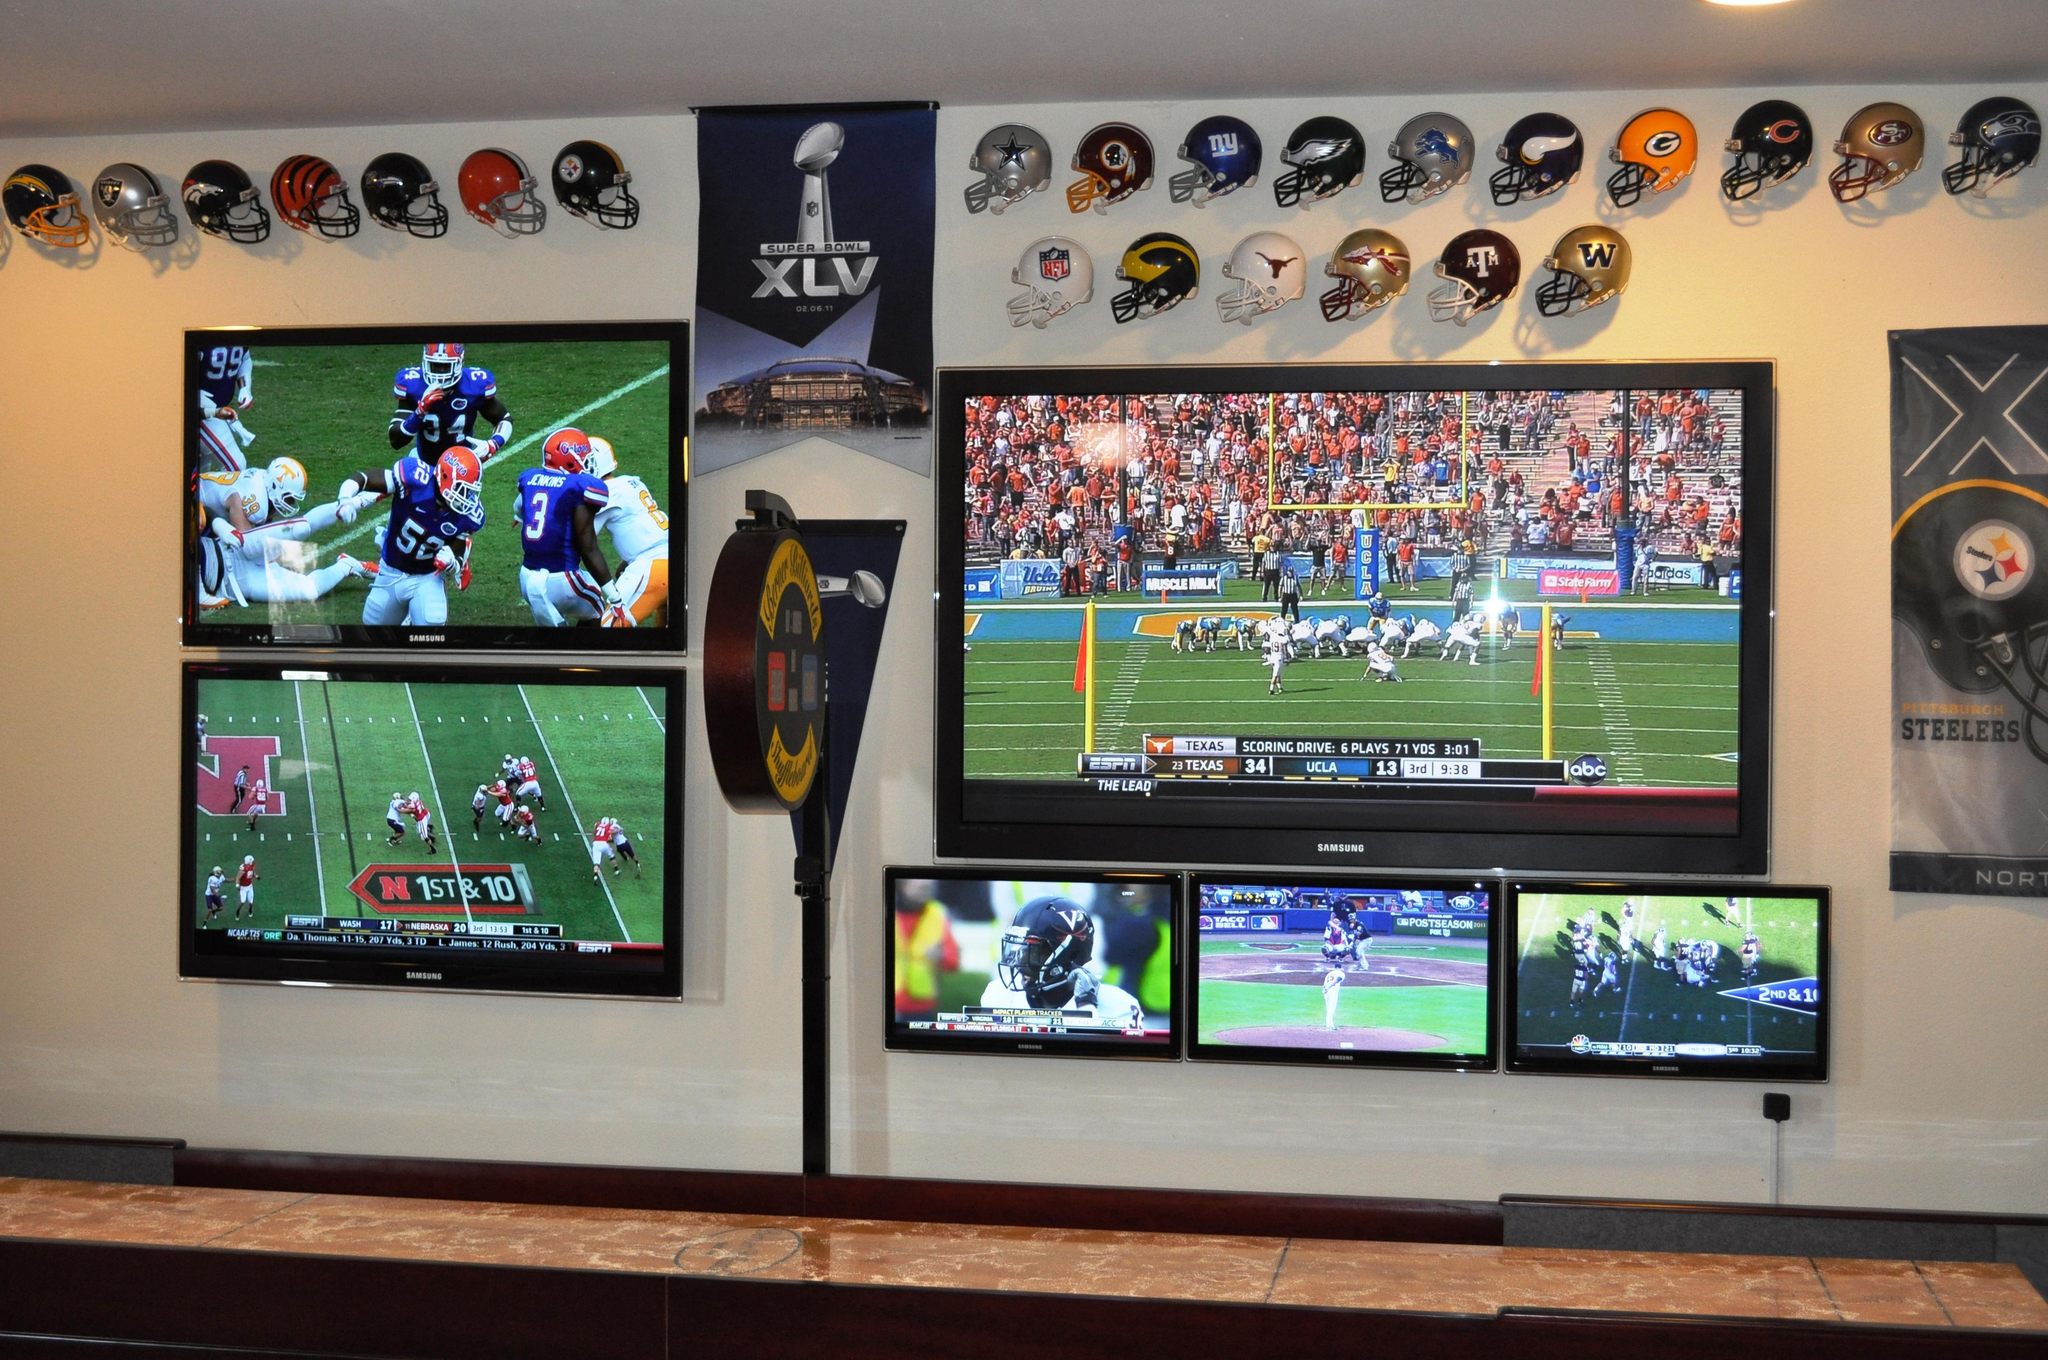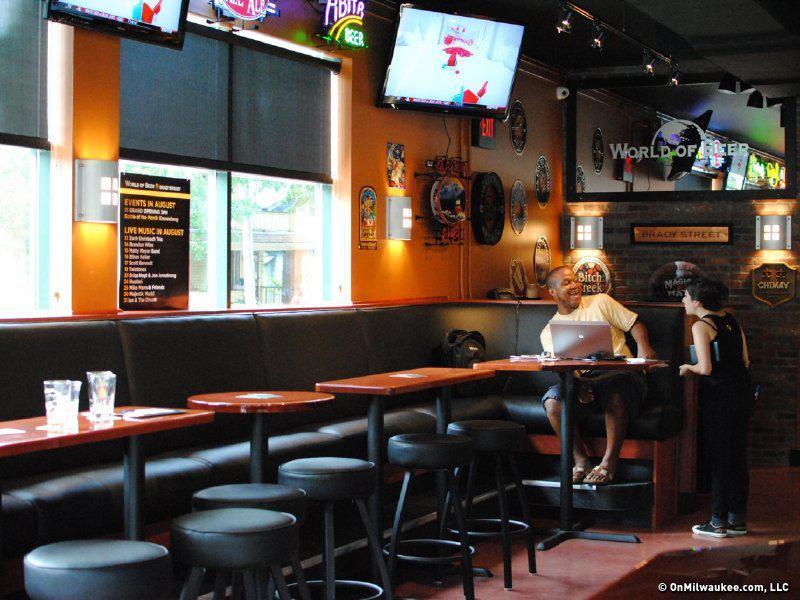The first image is the image on the left, the second image is the image on the right. For the images shown, is this caption "In one image, the restaurant with overhead television screens has seating on tall stools at tables with wooden tops." true? Answer yes or no. Yes. The first image is the image on the left, the second image is the image on the right. For the images displayed, is the sentence "An image shows at least one customer in a bar equipped with a suspended TV screen." factually correct? Answer yes or no. Yes. 